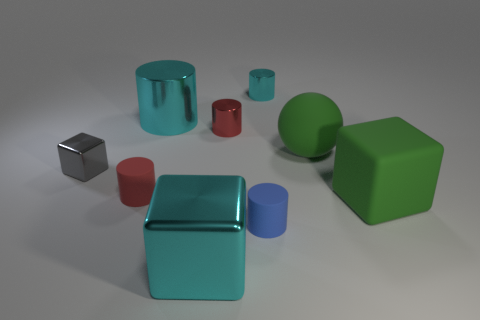Subtract 1 cylinders. How many cylinders are left? 4 Subtract all big cylinders. How many cylinders are left? 4 Subtract all blue cylinders. How many cylinders are left? 4 Subtract all yellow cylinders. Subtract all green cubes. How many cylinders are left? 5 Add 1 small yellow matte cylinders. How many objects exist? 10 Subtract all balls. How many objects are left? 8 Subtract 0 purple blocks. How many objects are left? 9 Subtract all large matte spheres. Subtract all tiny blue rubber objects. How many objects are left? 7 Add 7 small blue matte cylinders. How many small blue matte cylinders are left? 8 Add 4 small brown shiny blocks. How many small brown shiny blocks exist? 4 